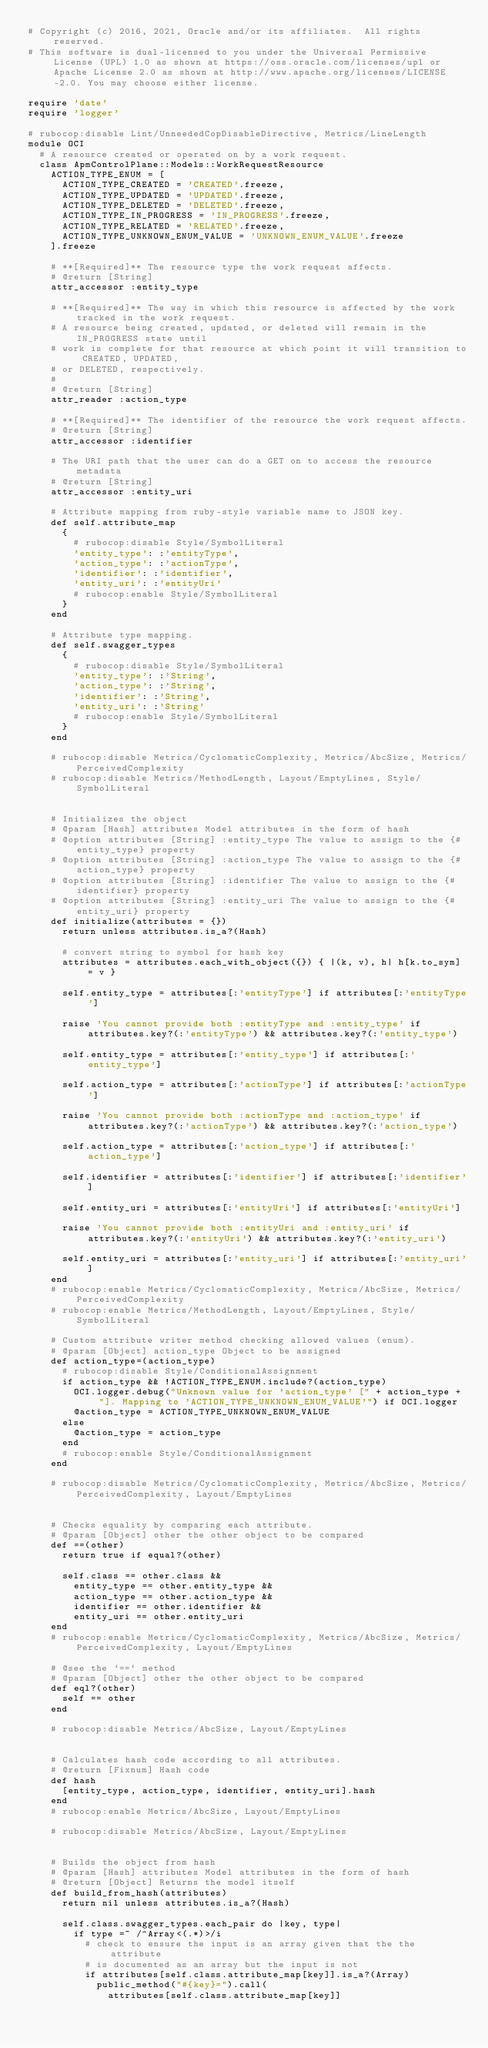<code> <loc_0><loc_0><loc_500><loc_500><_Ruby_># Copyright (c) 2016, 2021, Oracle and/or its affiliates.  All rights reserved.
# This software is dual-licensed to you under the Universal Permissive License (UPL) 1.0 as shown at https://oss.oracle.com/licenses/upl or Apache License 2.0 as shown at http://www.apache.org/licenses/LICENSE-2.0. You may choose either license.

require 'date'
require 'logger'

# rubocop:disable Lint/UnneededCopDisableDirective, Metrics/LineLength
module OCI
  # A resource created or operated on by a work request.
  class ApmControlPlane::Models::WorkRequestResource
    ACTION_TYPE_ENUM = [
      ACTION_TYPE_CREATED = 'CREATED'.freeze,
      ACTION_TYPE_UPDATED = 'UPDATED'.freeze,
      ACTION_TYPE_DELETED = 'DELETED'.freeze,
      ACTION_TYPE_IN_PROGRESS = 'IN_PROGRESS'.freeze,
      ACTION_TYPE_RELATED = 'RELATED'.freeze,
      ACTION_TYPE_UNKNOWN_ENUM_VALUE = 'UNKNOWN_ENUM_VALUE'.freeze
    ].freeze

    # **[Required]** The resource type the work request affects.
    # @return [String]
    attr_accessor :entity_type

    # **[Required]** The way in which this resource is affected by the work tracked in the work request.
    # A resource being created, updated, or deleted will remain in the IN_PROGRESS state until
    # work is complete for that resource at which point it will transition to CREATED, UPDATED,
    # or DELETED, respectively.
    #
    # @return [String]
    attr_reader :action_type

    # **[Required]** The identifier of the resource the work request affects.
    # @return [String]
    attr_accessor :identifier

    # The URI path that the user can do a GET on to access the resource metadata
    # @return [String]
    attr_accessor :entity_uri

    # Attribute mapping from ruby-style variable name to JSON key.
    def self.attribute_map
      {
        # rubocop:disable Style/SymbolLiteral
        'entity_type': :'entityType',
        'action_type': :'actionType',
        'identifier': :'identifier',
        'entity_uri': :'entityUri'
        # rubocop:enable Style/SymbolLiteral
      }
    end

    # Attribute type mapping.
    def self.swagger_types
      {
        # rubocop:disable Style/SymbolLiteral
        'entity_type': :'String',
        'action_type': :'String',
        'identifier': :'String',
        'entity_uri': :'String'
        # rubocop:enable Style/SymbolLiteral
      }
    end

    # rubocop:disable Metrics/CyclomaticComplexity, Metrics/AbcSize, Metrics/PerceivedComplexity
    # rubocop:disable Metrics/MethodLength, Layout/EmptyLines, Style/SymbolLiteral


    # Initializes the object
    # @param [Hash] attributes Model attributes in the form of hash
    # @option attributes [String] :entity_type The value to assign to the {#entity_type} property
    # @option attributes [String] :action_type The value to assign to the {#action_type} property
    # @option attributes [String] :identifier The value to assign to the {#identifier} property
    # @option attributes [String] :entity_uri The value to assign to the {#entity_uri} property
    def initialize(attributes = {})
      return unless attributes.is_a?(Hash)

      # convert string to symbol for hash key
      attributes = attributes.each_with_object({}) { |(k, v), h| h[k.to_sym] = v }

      self.entity_type = attributes[:'entityType'] if attributes[:'entityType']

      raise 'You cannot provide both :entityType and :entity_type' if attributes.key?(:'entityType') && attributes.key?(:'entity_type')

      self.entity_type = attributes[:'entity_type'] if attributes[:'entity_type']

      self.action_type = attributes[:'actionType'] if attributes[:'actionType']

      raise 'You cannot provide both :actionType and :action_type' if attributes.key?(:'actionType') && attributes.key?(:'action_type')

      self.action_type = attributes[:'action_type'] if attributes[:'action_type']

      self.identifier = attributes[:'identifier'] if attributes[:'identifier']

      self.entity_uri = attributes[:'entityUri'] if attributes[:'entityUri']

      raise 'You cannot provide both :entityUri and :entity_uri' if attributes.key?(:'entityUri') && attributes.key?(:'entity_uri')

      self.entity_uri = attributes[:'entity_uri'] if attributes[:'entity_uri']
    end
    # rubocop:enable Metrics/CyclomaticComplexity, Metrics/AbcSize, Metrics/PerceivedComplexity
    # rubocop:enable Metrics/MethodLength, Layout/EmptyLines, Style/SymbolLiteral

    # Custom attribute writer method checking allowed values (enum).
    # @param [Object] action_type Object to be assigned
    def action_type=(action_type)
      # rubocop:disable Style/ConditionalAssignment
      if action_type && !ACTION_TYPE_ENUM.include?(action_type)
        OCI.logger.debug("Unknown value for 'action_type' [" + action_type + "]. Mapping to 'ACTION_TYPE_UNKNOWN_ENUM_VALUE'") if OCI.logger
        @action_type = ACTION_TYPE_UNKNOWN_ENUM_VALUE
      else
        @action_type = action_type
      end
      # rubocop:enable Style/ConditionalAssignment
    end

    # rubocop:disable Metrics/CyclomaticComplexity, Metrics/AbcSize, Metrics/PerceivedComplexity, Layout/EmptyLines


    # Checks equality by comparing each attribute.
    # @param [Object] other the other object to be compared
    def ==(other)
      return true if equal?(other)

      self.class == other.class &&
        entity_type == other.entity_type &&
        action_type == other.action_type &&
        identifier == other.identifier &&
        entity_uri == other.entity_uri
    end
    # rubocop:enable Metrics/CyclomaticComplexity, Metrics/AbcSize, Metrics/PerceivedComplexity, Layout/EmptyLines

    # @see the `==` method
    # @param [Object] other the other object to be compared
    def eql?(other)
      self == other
    end

    # rubocop:disable Metrics/AbcSize, Layout/EmptyLines


    # Calculates hash code according to all attributes.
    # @return [Fixnum] Hash code
    def hash
      [entity_type, action_type, identifier, entity_uri].hash
    end
    # rubocop:enable Metrics/AbcSize, Layout/EmptyLines

    # rubocop:disable Metrics/AbcSize, Layout/EmptyLines


    # Builds the object from hash
    # @param [Hash] attributes Model attributes in the form of hash
    # @return [Object] Returns the model itself
    def build_from_hash(attributes)
      return nil unless attributes.is_a?(Hash)

      self.class.swagger_types.each_pair do |key, type|
        if type =~ /^Array<(.*)>/i
          # check to ensure the input is an array given that the the attribute
          # is documented as an array but the input is not
          if attributes[self.class.attribute_map[key]].is_a?(Array)
            public_method("#{key}=").call(
              attributes[self.class.attribute_map[key]]</code> 